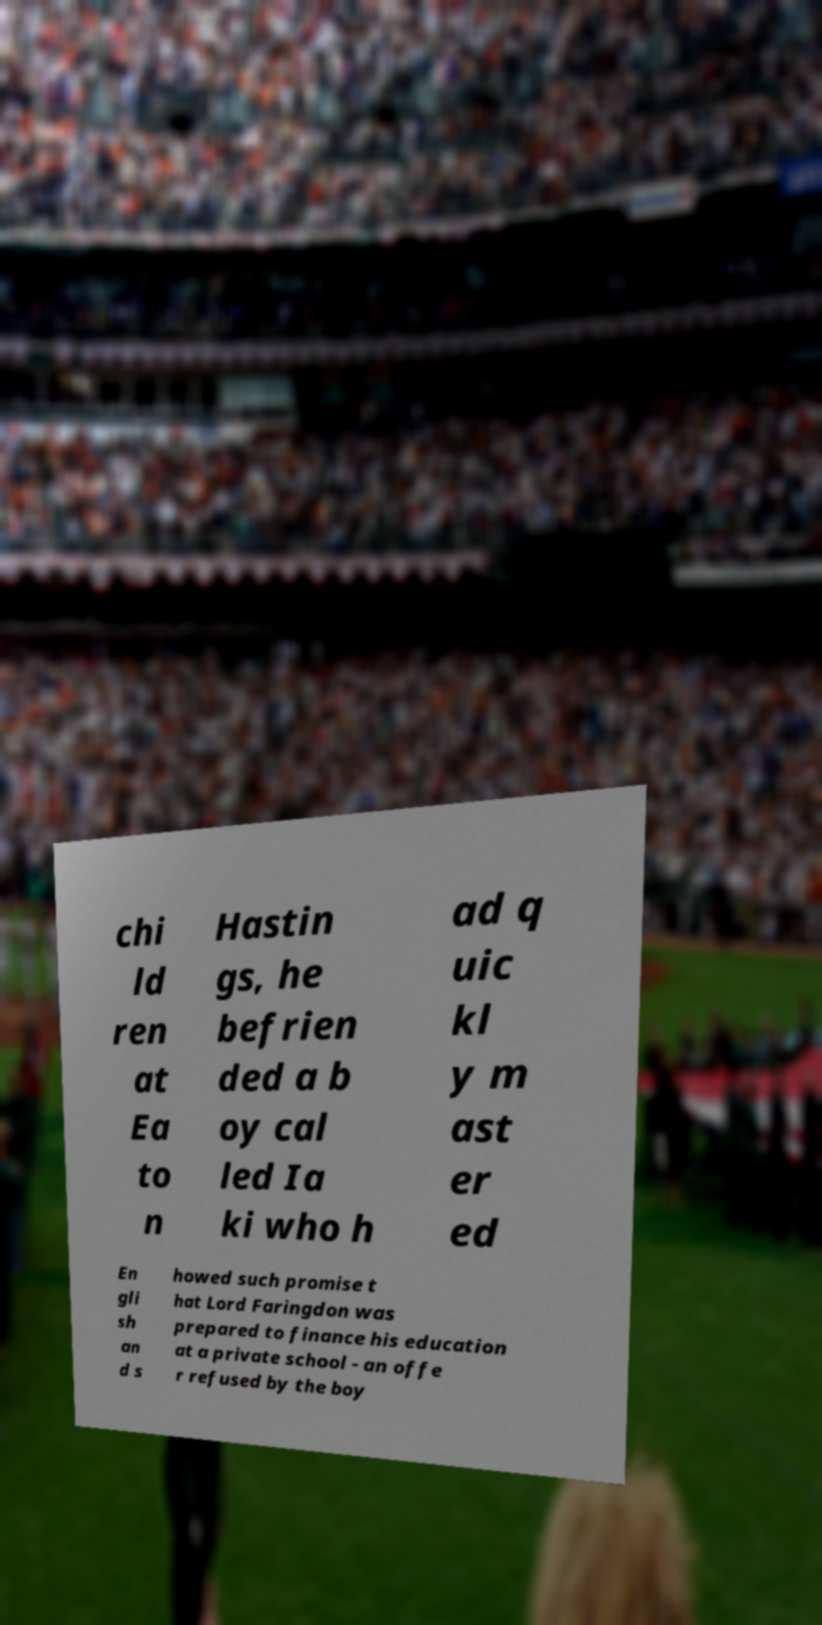Can you accurately transcribe the text from the provided image for me? chi ld ren at Ea to n Hastin gs, he befrien ded a b oy cal led Ia ki who h ad q uic kl y m ast er ed En gli sh an d s howed such promise t hat Lord Faringdon was prepared to finance his education at a private school - an offe r refused by the boy 